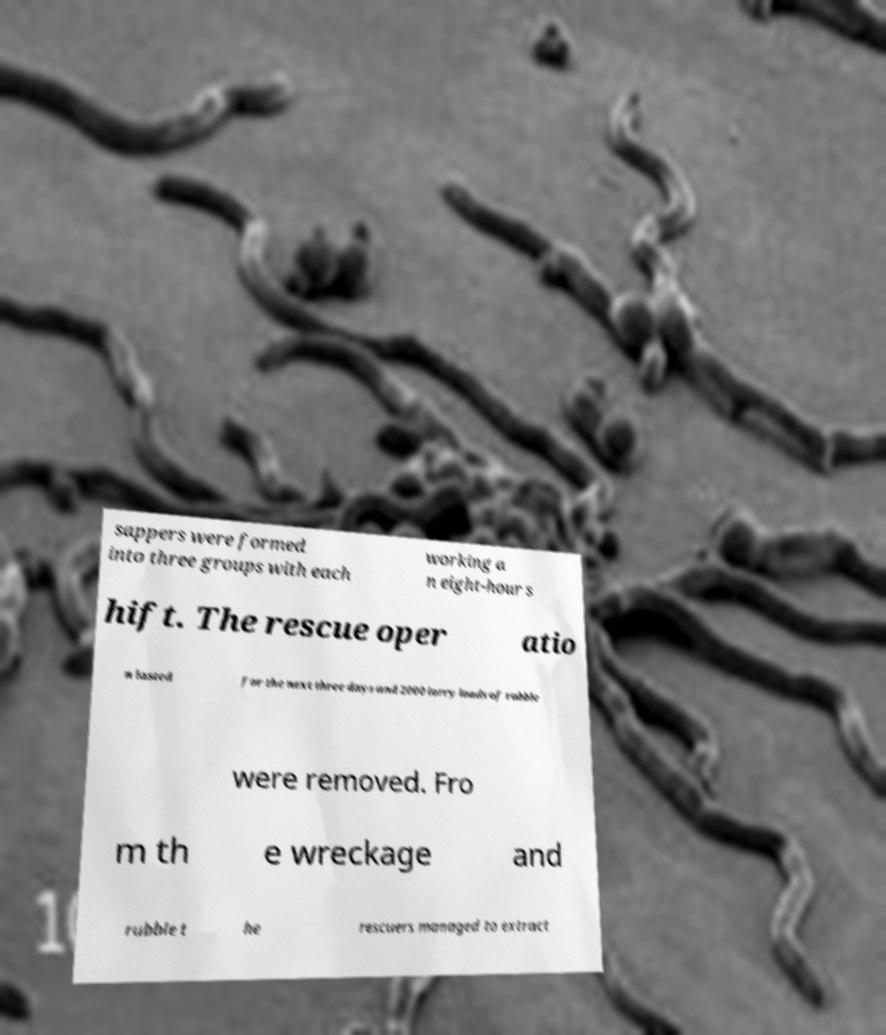Please identify and transcribe the text found in this image. sappers were formed into three groups with each working a n eight-hour s hift. The rescue oper atio n lasted for the next three days and 2000 lorry loads of rubble were removed. Fro m th e wreckage and rubble t he rescuers managed to extract 